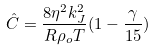<formula> <loc_0><loc_0><loc_500><loc_500>\hat { C } = \frac { 8 \eta ^ { 2 } k _ { J } ^ { 2 } } { R \rho _ { o } T } ( 1 - \frac { \gamma } { 1 5 } )</formula> 